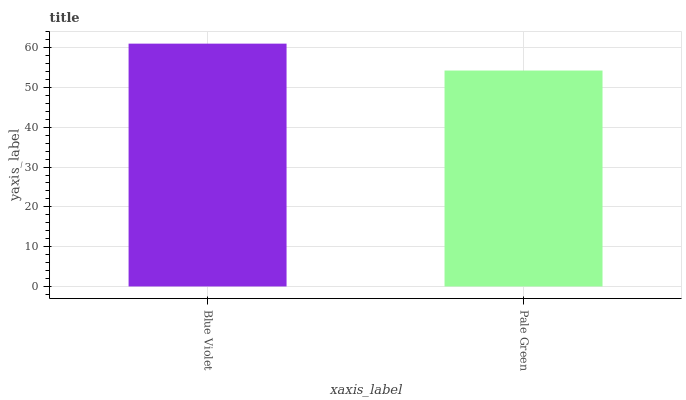Is Pale Green the minimum?
Answer yes or no. Yes. Is Blue Violet the maximum?
Answer yes or no. Yes. Is Pale Green the maximum?
Answer yes or no. No. Is Blue Violet greater than Pale Green?
Answer yes or no. Yes. Is Pale Green less than Blue Violet?
Answer yes or no. Yes. Is Pale Green greater than Blue Violet?
Answer yes or no. No. Is Blue Violet less than Pale Green?
Answer yes or no. No. Is Blue Violet the high median?
Answer yes or no. Yes. Is Pale Green the low median?
Answer yes or no. Yes. Is Pale Green the high median?
Answer yes or no. No. Is Blue Violet the low median?
Answer yes or no. No. 